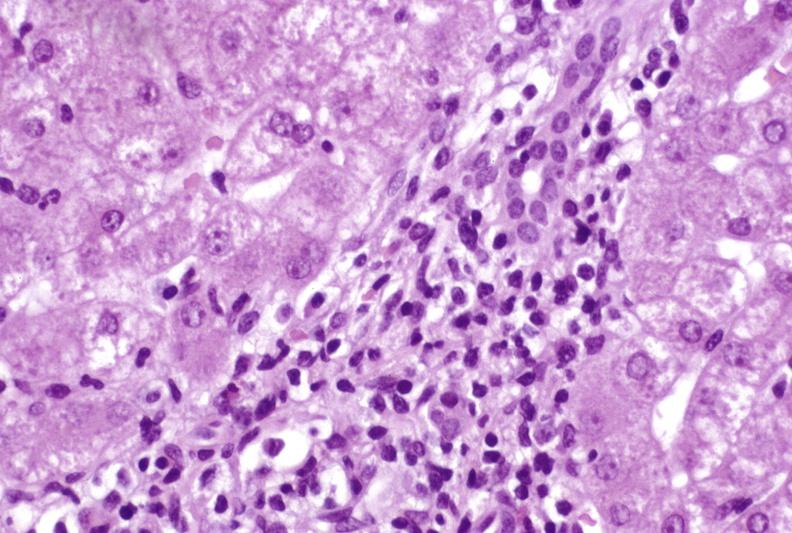s fracture present?
Answer the question using a single word or phrase. No 